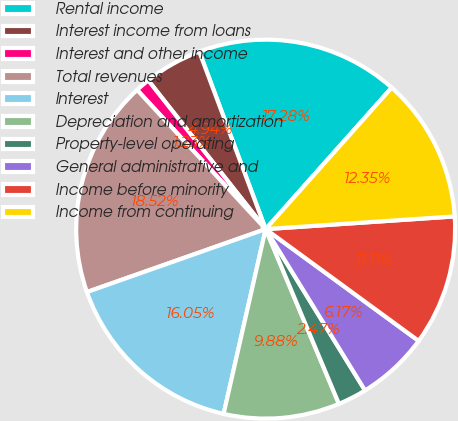Convert chart to OTSL. <chart><loc_0><loc_0><loc_500><loc_500><pie_chart><fcel>Rental income<fcel>Interest income from loans<fcel>Interest and other income<fcel>Total revenues<fcel>Interest<fcel>Depreciation and amortization<fcel>Property-level operating<fcel>General administrative and<fcel>Income before minority<fcel>Income from continuing<nl><fcel>17.28%<fcel>4.94%<fcel>1.23%<fcel>18.52%<fcel>16.05%<fcel>9.88%<fcel>2.47%<fcel>6.17%<fcel>11.11%<fcel>12.35%<nl></chart> 